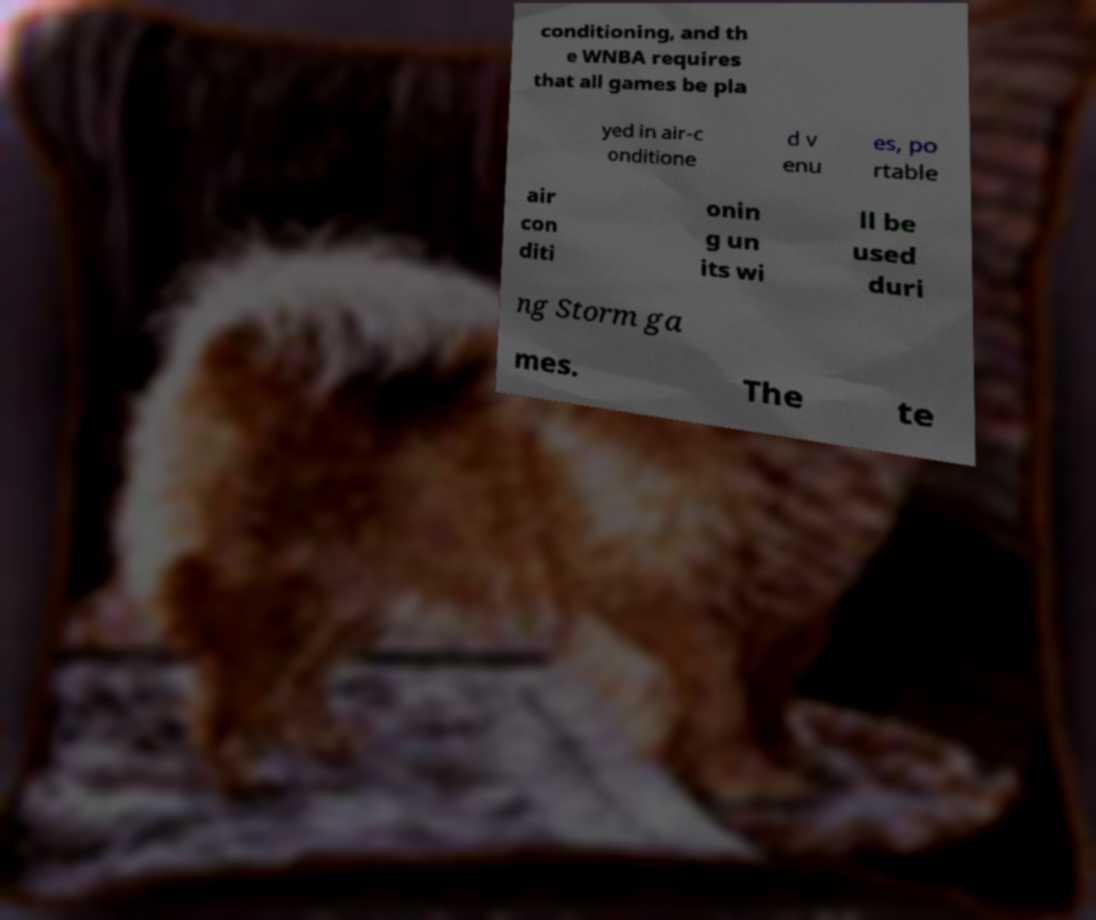Please identify and transcribe the text found in this image. conditioning, and th e WNBA requires that all games be pla yed in air-c onditione d v enu es, po rtable air con diti onin g un its wi ll be used duri ng Storm ga mes. The te 